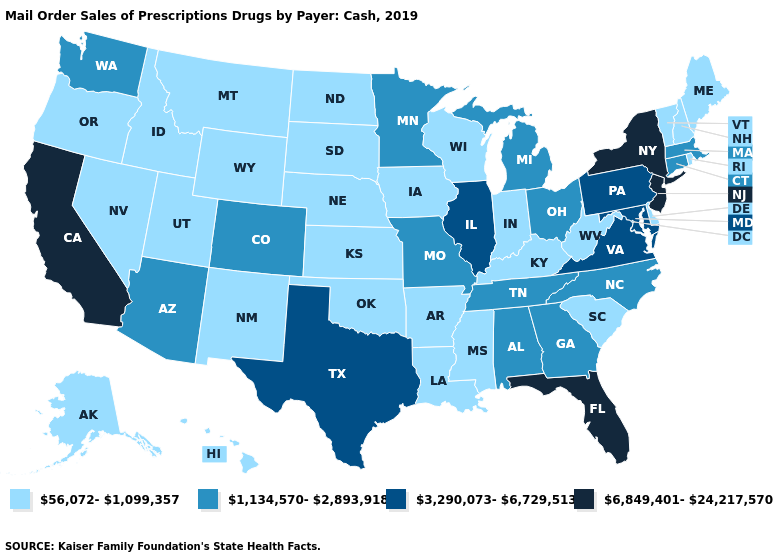What is the highest value in the USA?
Be succinct. 6,849,401-24,217,570. Does Georgia have a lower value than California?
Concise answer only. Yes. What is the value of Vermont?
Short answer required. 56,072-1,099,357. Does Pennsylvania have the highest value in the USA?
Short answer required. No. Does Missouri have a lower value than Maryland?
Concise answer only. Yes. Does the first symbol in the legend represent the smallest category?
Concise answer only. Yes. Name the states that have a value in the range 1,134,570-2,893,918?
Keep it brief. Alabama, Arizona, Colorado, Connecticut, Georgia, Massachusetts, Michigan, Minnesota, Missouri, North Carolina, Ohio, Tennessee, Washington. Which states hav the highest value in the MidWest?
Write a very short answer. Illinois. Does the first symbol in the legend represent the smallest category?
Quick response, please. Yes. What is the highest value in the MidWest ?
Write a very short answer. 3,290,073-6,729,513. Which states have the highest value in the USA?
Give a very brief answer. California, Florida, New Jersey, New York. Which states have the lowest value in the USA?
Concise answer only. Alaska, Arkansas, Delaware, Hawaii, Idaho, Indiana, Iowa, Kansas, Kentucky, Louisiana, Maine, Mississippi, Montana, Nebraska, Nevada, New Hampshire, New Mexico, North Dakota, Oklahoma, Oregon, Rhode Island, South Carolina, South Dakota, Utah, Vermont, West Virginia, Wisconsin, Wyoming. Which states have the highest value in the USA?
Give a very brief answer. California, Florida, New Jersey, New York. What is the highest value in the South ?
Write a very short answer. 6,849,401-24,217,570. Which states have the highest value in the USA?
Give a very brief answer. California, Florida, New Jersey, New York. 